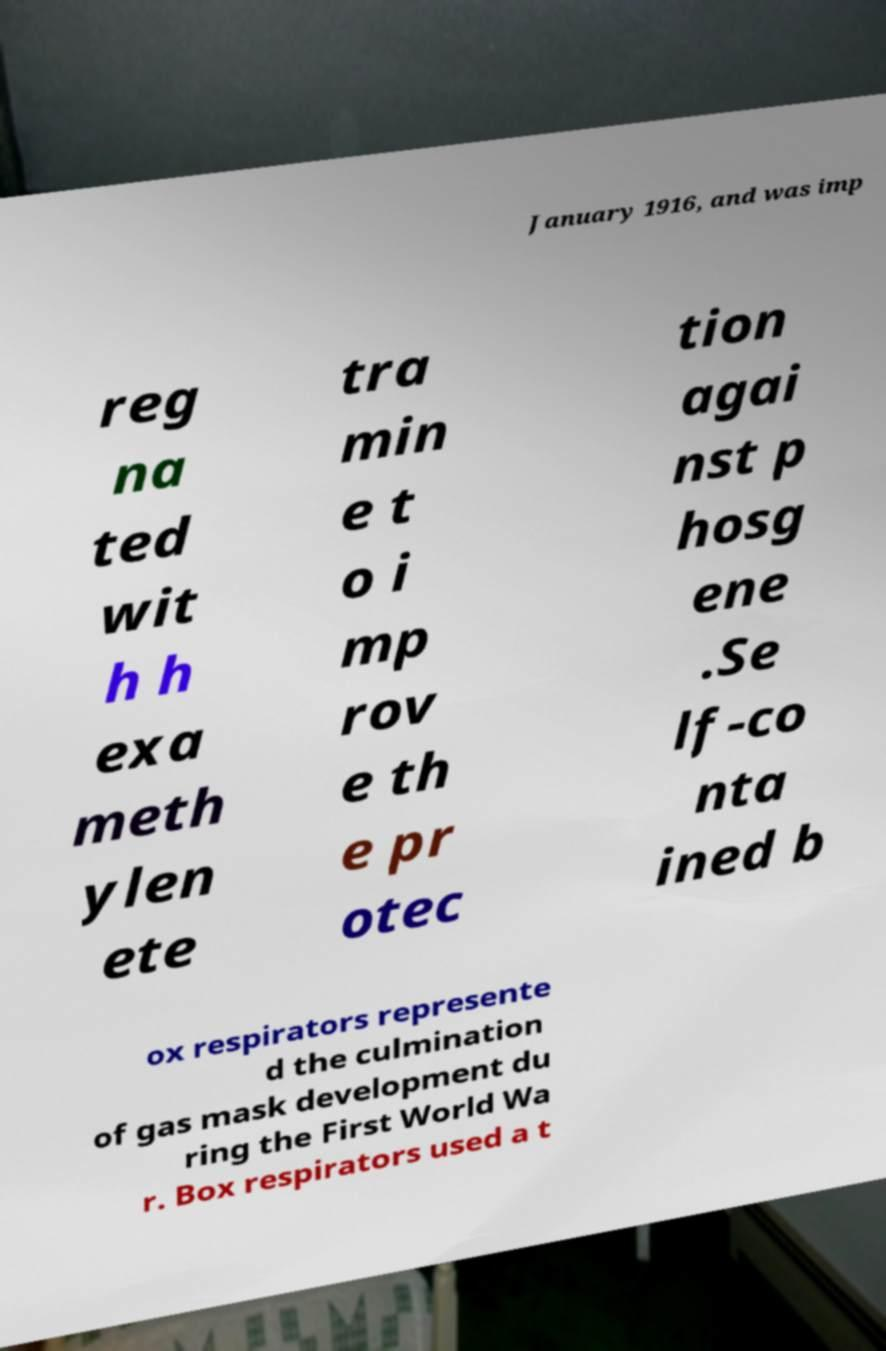Can you read and provide the text displayed in the image?This photo seems to have some interesting text. Can you extract and type it out for me? January 1916, and was imp reg na ted wit h h exa meth ylen ete tra min e t o i mp rov e th e pr otec tion agai nst p hosg ene .Se lf-co nta ined b ox respirators represente d the culmination of gas mask development du ring the First World Wa r. Box respirators used a t 